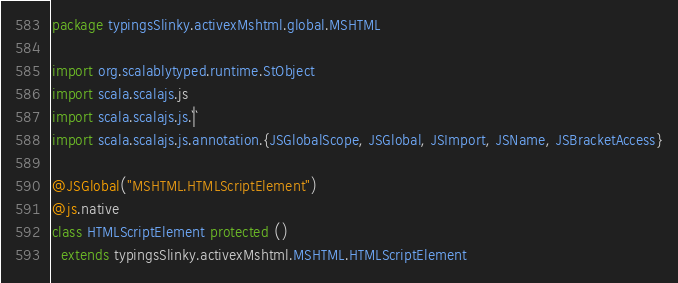<code> <loc_0><loc_0><loc_500><loc_500><_Scala_>package typingsSlinky.activexMshtml.global.MSHTML

import org.scalablytyped.runtime.StObject
import scala.scalajs.js
import scala.scalajs.js.`|`
import scala.scalajs.js.annotation.{JSGlobalScope, JSGlobal, JSImport, JSName, JSBracketAccess}

@JSGlobal("MSHTML.HTMLScriptElement")
@js.native
class HTMLScriptElement protected ()
  extends typingsSlinky.activexMshtml.MSHTML.HTMLScriptElement
</code> 